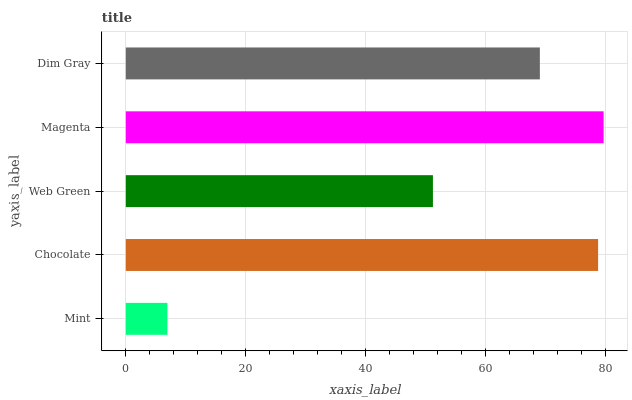Is Mint the minimum?
Answer yes or no. Yes. Is Magenta the maximum?
Answer yes or no. Yes. Is Chocolate the minimum?
Answer yes or no. No. Is Chocolate the maximum?
Answer yes or no. No. Is Chocolate greater than Mint?
Answer yes or no. Yes. Is Mint less than Chocolate?
Answer yes or no. Yes. Is Mint greater than Chocolate?
Answer yes or no. No. Is Chocolate less than Mint?
Answer yes or no. No. Is Dim Gray the high median?
Answer yes or no. Yes. Is Dim Gray the low median?
Answer yes or no. Yes. Is Magenta the high median?
Answer yes or no. No. Is Magenta the low median?
Answer yes or no. No. 